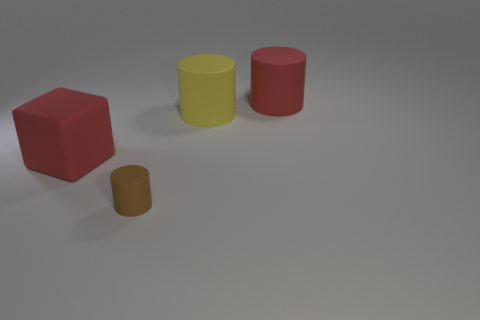What number of other things are the same size as the brown object?
Your answer should be very brief. 0. There is a object that is both in front of the large red cylinder and to the right of the brown matte cylinder; what is its material?
Your response must be concise. Rubber. What number of yellow matte things have the same shape as the small brown rubber object?
Give a very brief answer. 1. How many objects are either things behind the tiny matte cylinder or large yellow matte objects?
Provide a succinct answer. 3. There is a red rubber object in front of the cylinder behind the large yellow object behind the brown cylinder; what shape is it?
Your response must be concise. Cube. What is the shape of the yellow thing that is made of the same material as the brown thing?
Provide a succinct answer. Cylinder. What is the size of the red cylinder?
Provide a short and direct response. Large. Do the cube and the brown matte thing have the same size?
Provide a succinct answer. No. What number of things are red rubber things that are on the left side of the red cylinder or red rubber cubes behind the tiny matte object?
Provide a succinct answer. 1. What number of tiny matte objects are on the left side of the red thing on the left side of the large red object to the right of the large matte cube?
Give a very brief answer. 0. 